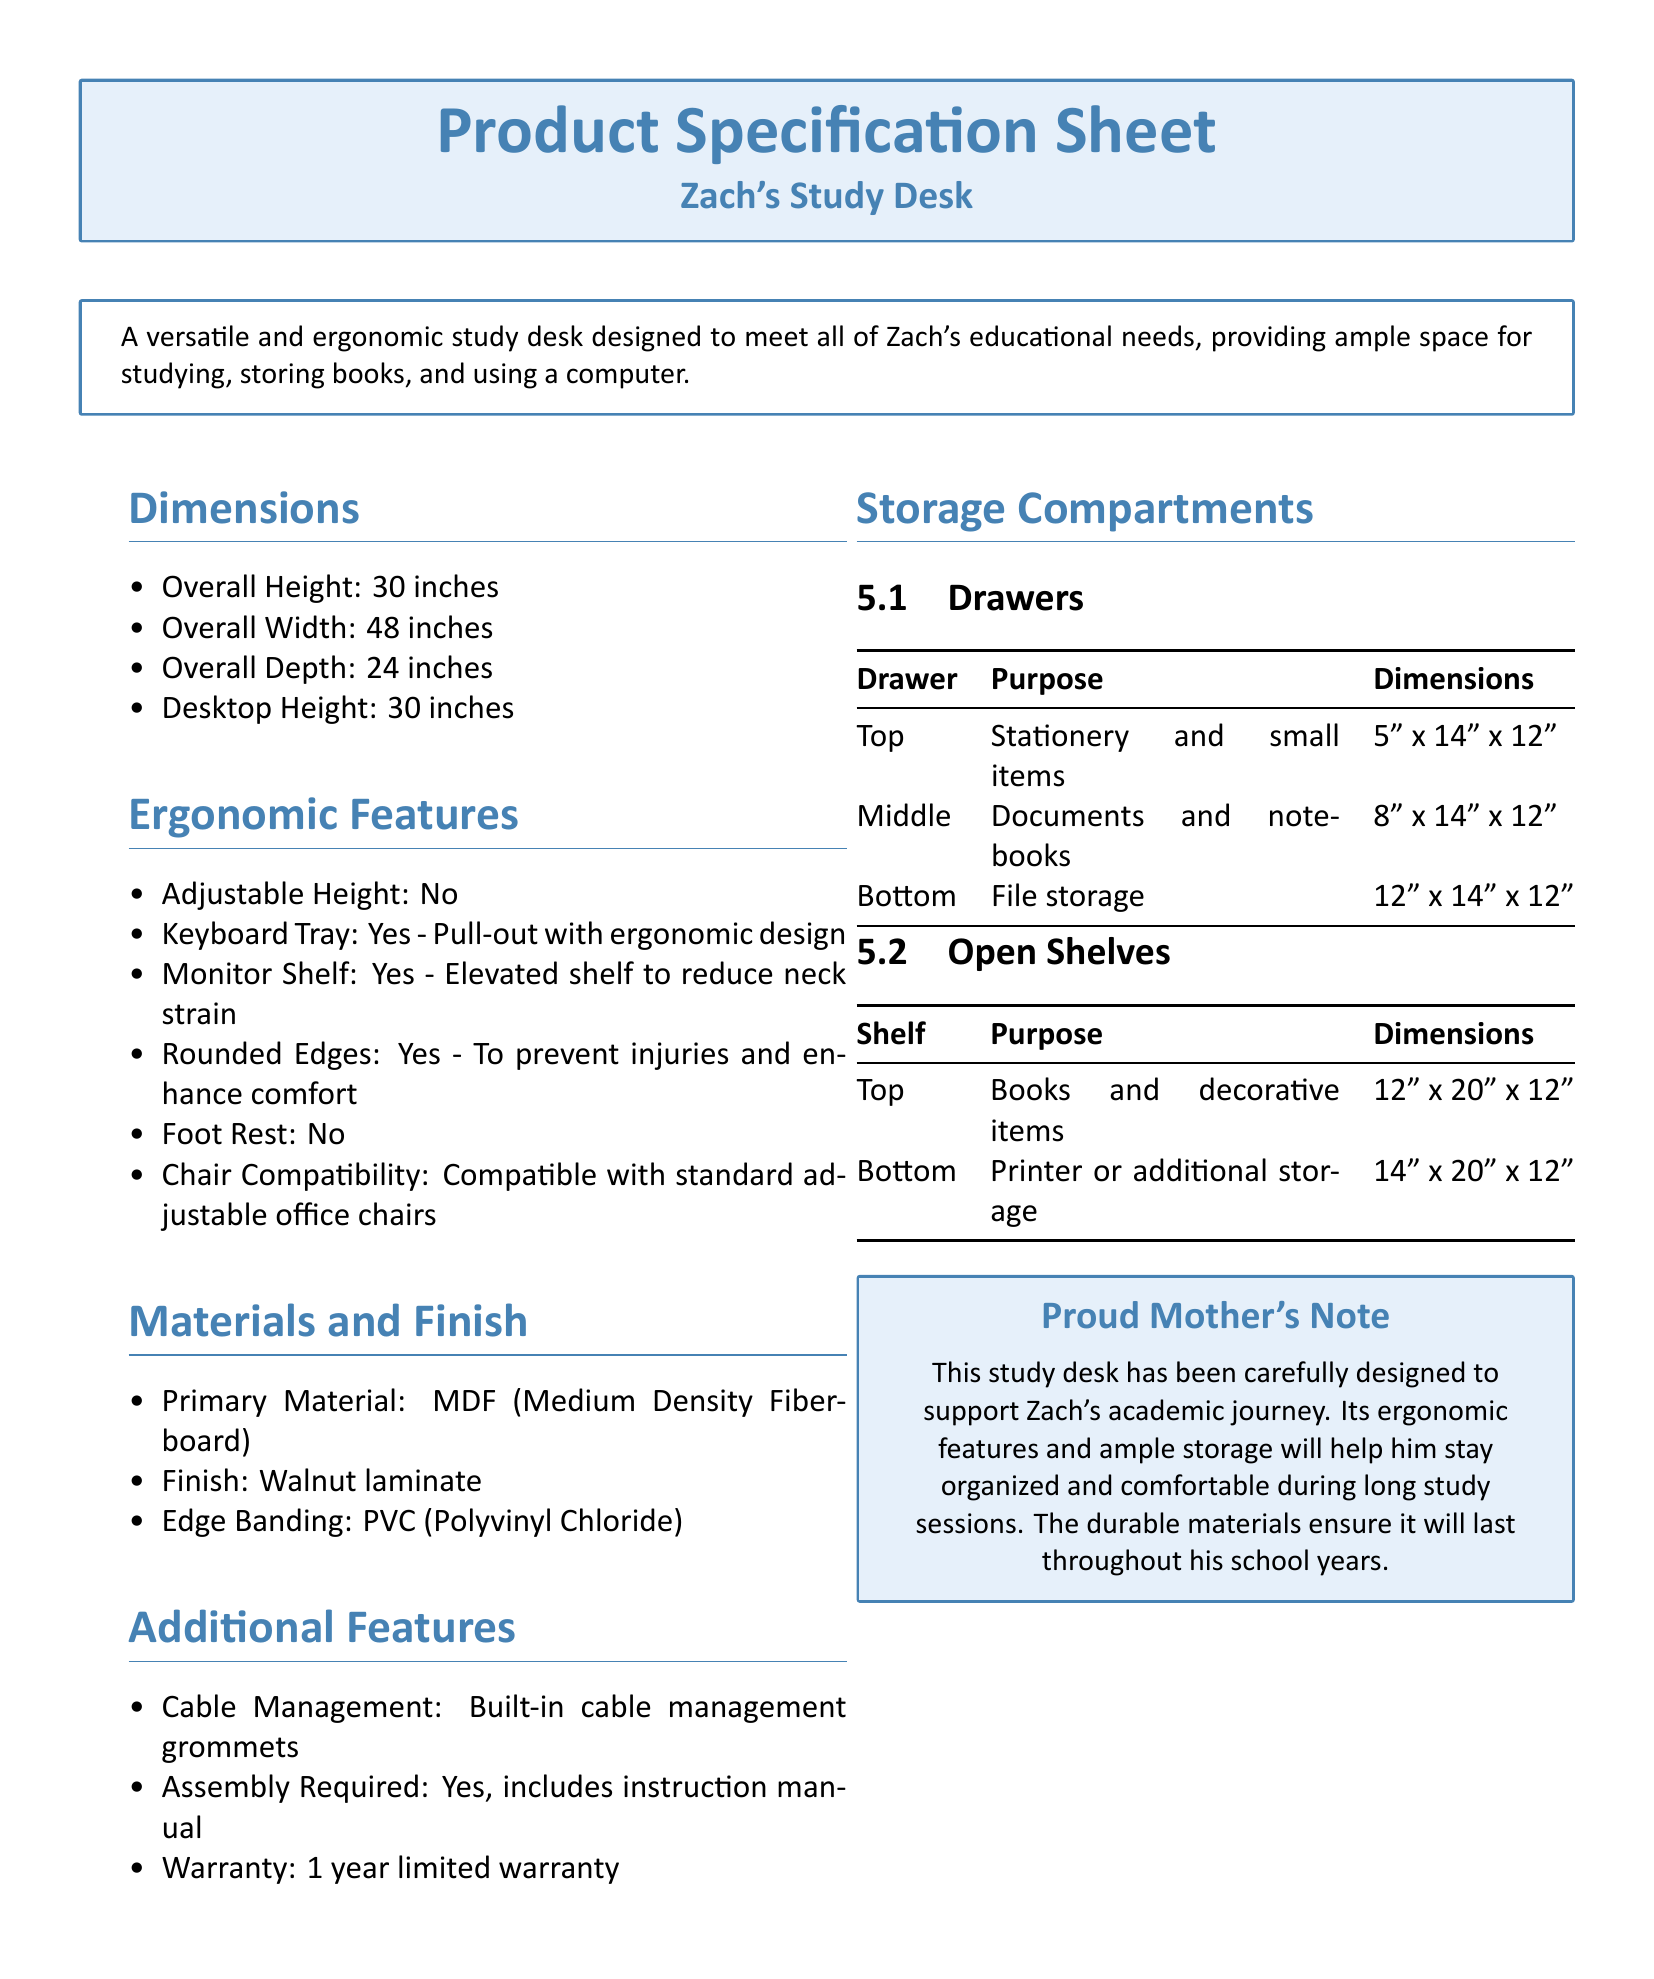what is the overall height of the desk? The overall height is specified under the Dimensions section of the document, which states it is 30 inches.
Answer: 30 inches what is the material used for the desk? The Primary Material is mentioned in the Materials and Finish section, which states that it is MDF (Medium Density Fiberboard).
Answer: MDF how many drawers does the desk have? The Storage Compartments section details three types of drawers: top, middle, and bottom. Therefore, the desk has three drawers.
Answer: Three what is the width of the middle drawer? The middle drawer's dimensions are provided in the Storage Compartments section, where it is listed as 8 inches.
Answer: 8 inches is the desk adjustable in height? The Ergonomic Features section directly states that the desk does not have adjustable height, making this a straightforward answer.
Answer: No what is the warranty period for the desk? The Additional Features section mentions that the desk comes with a 1 year limited warranty.
Answer: 1 year what type of finish does the desk have? In the Materials and Finish section, it is specified that the desk has a Walnut laminate finish.
Answer: Walnut laminate what can be stored in the top shelf? The Storage Compartments section lists that the top shelf is for Books and decorative items.
Answer: Books and decorative items what ergonomic feature is included for keyboard usage? The Ergonomic Features section indicates that there is a pull-out Keyboard Tray designed ergonomically.
Answer: Pull-out keyboard tray 